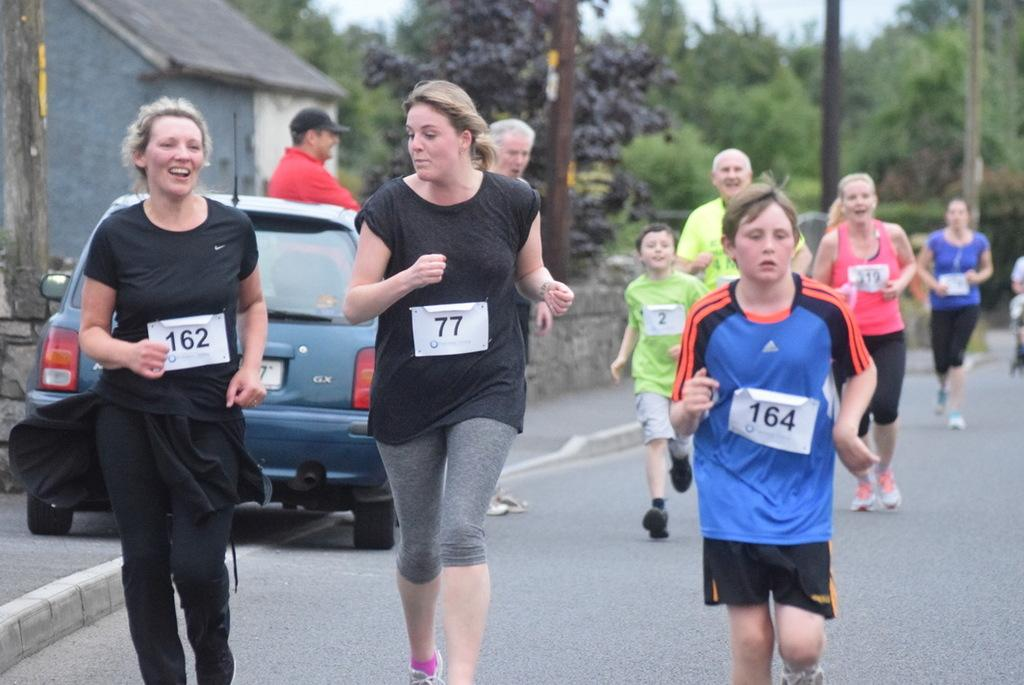What are the people in the image doing? There is a group of people running on the road in the image. What else can be seen in the image besides the people running? There is a car, a house, trees, poles, and the sky visible in the image. What type of quill is being used by the person in the image? There is no person using a quill in the image; it features a group of people running on the road. Is there a bed visible in the image? No, there is no bed present in the image. 